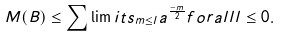Convert formula to latex. <formula><loc_0><loc_0><loc_500><loc_500>M ( B ) \leq \sum \lim i t s _ { m \leq l } a ^ { \frac { - m } { 2 } } f o r a l l l \leq 0 .</formula> 